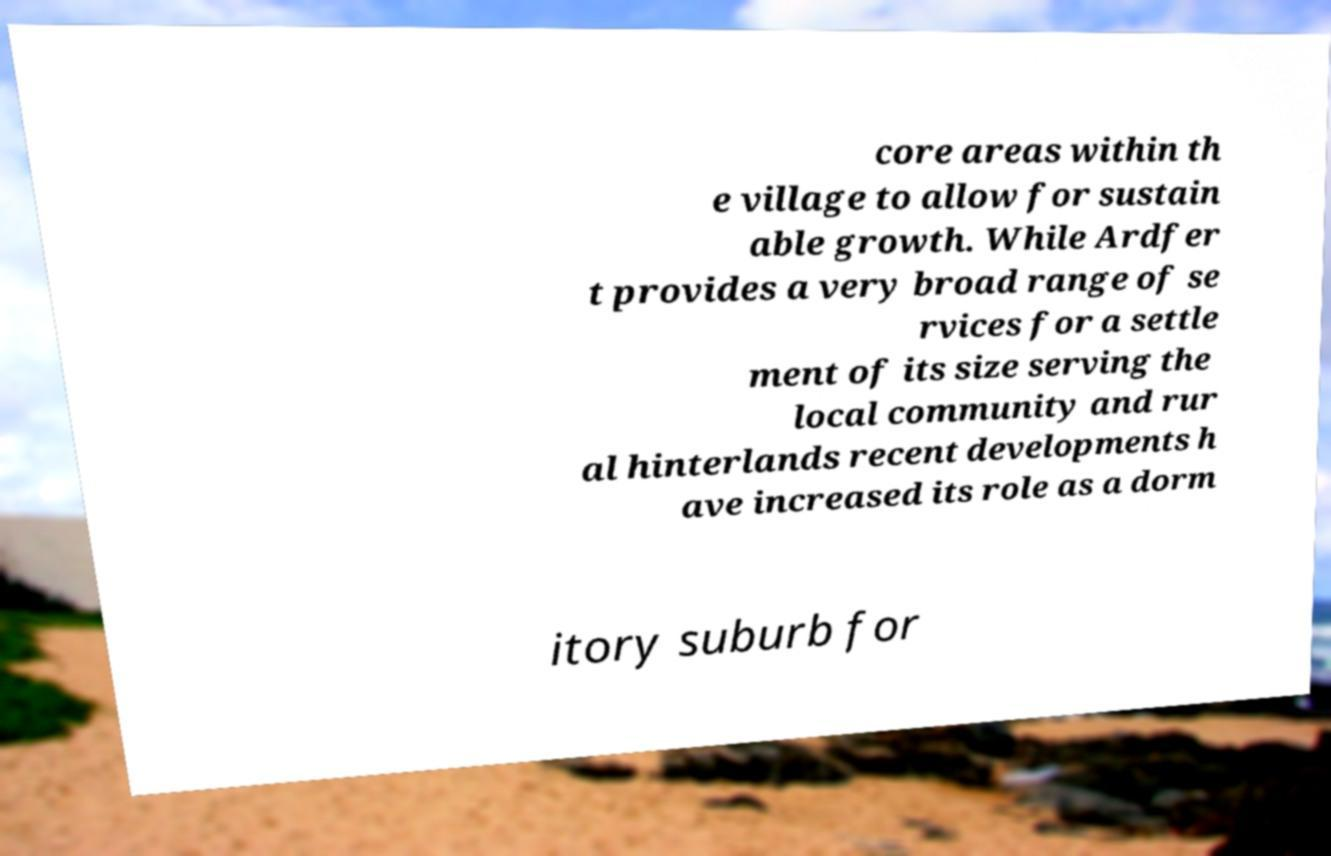Can you accurately transcribe the text from the provided image for me? core areas within th e village to allow for sustain able growth. While Ardfer t provides a very broad range of se rvices for a settle ment of its size serving the local community and rur al hinterlands recent developments h ave increased its role as a dorm itory suburb for 